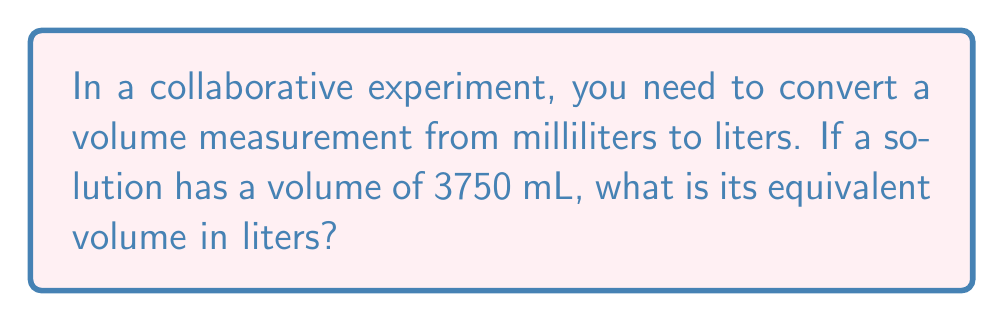Solve this math problem. Let's approach this step-by-step:

1. Recall the relationship between milliliters (mL) and liters (L):
   $1 \text{ L} = 1000 \text{ mL}$

2. Set up a conversion factor:
   $\frac{1 \text{ L}}{1000 \text{ mL}}$

3. Multiply the given volume by this conversion factor:
   $$3750 \text{ mL} \times \frac{1 \text{ L}}{1000 \text{ mL}}$$

4. Cancel out the units of mL:
   $$3750 \cancel{\text{ mL}} \times \frac{1 \text{ L}}{1000 \cancel{\text{ mL}}} = \frac{3750}{1000} \text{ L}$$

5. Simplify the fraction:
   $$\frac{3750}{1000} \text{ L} = 3.75 \text{ L}$$

Therefore, 3750 mL is equivalent to 3.75 L.
Answer: 3.75 L 